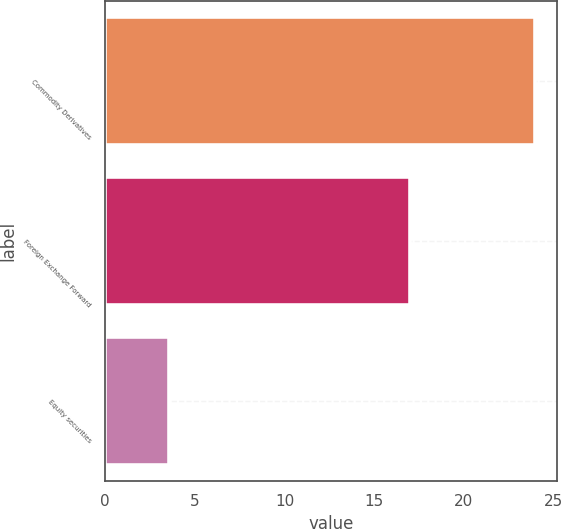Convert chart. <chart><loc_0><loc_0><loc_500><loc_500><bar_chart><fcel>Commodity Derivatives<fcel>Foreign Exchange Forward<fcel>Equity securities<nl><fcel>24<fcel>17<fcel>3.57<nl></chart> 